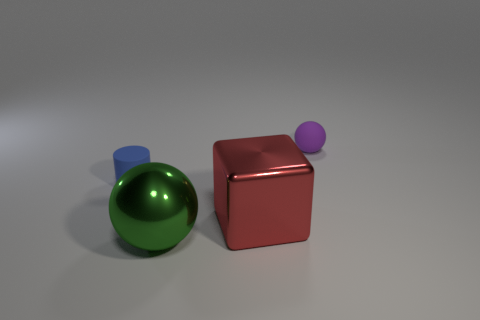Add 4 small blue matte objects. How many objects exist? 8 Subtract all cylinders. How many objects are left? 3 Add 4 tiny blue rubber objects. How many tiny blue rubber objects exist? 5 Subtract 0 brown cubes. How many objects are left? 4 Subtract all tiny purple objects. Subtract all small rubber objects. How many objects are left? 1 Add 4 balls. How many balls are left? 6 